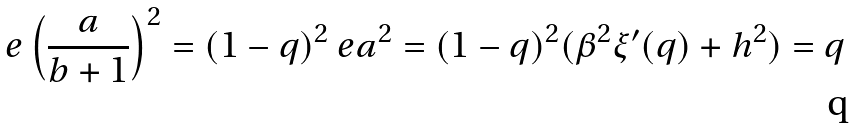Convert formula to latex. <formula><loc_0><loc_0><loc_500><loc_500>\ e \left ( \frac { a } { b + 1 } \right ) ^ { 2 } = ( 1 - q ) ^ { 2 } \ e a ^ { 2 } = ( 1 - q ) ^ { 2 } ( \beta ^ { 2 } \xi ^ { \prime } ( q ) + h ^ { 2 } ) = q</formula> 